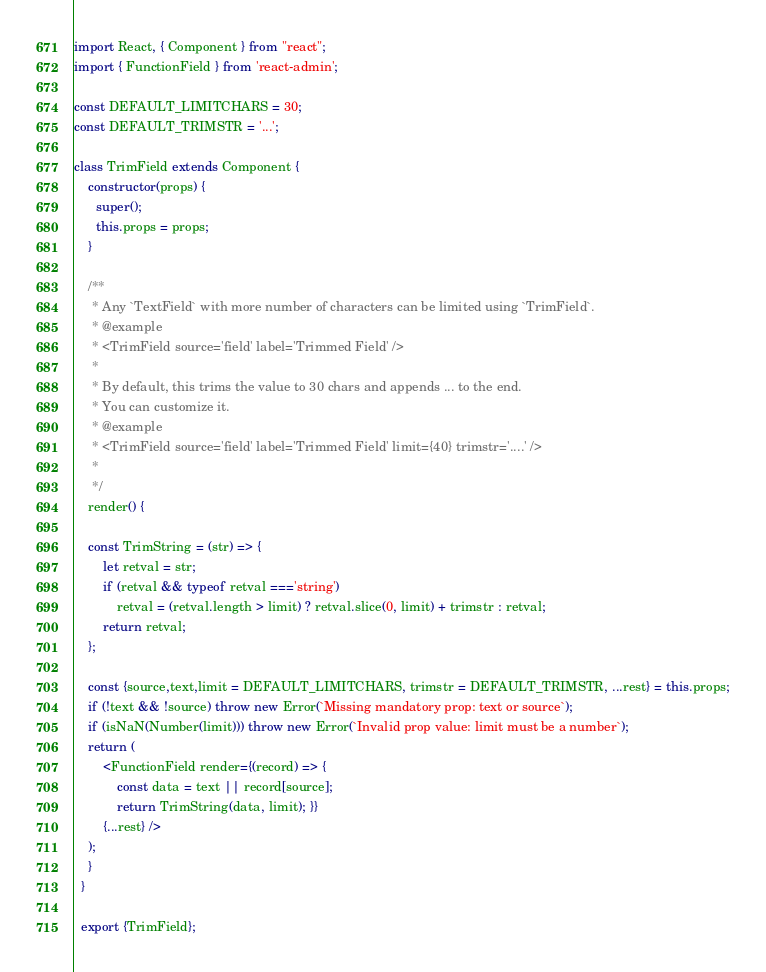<code> <loc_0><loc_0><loc_500><loc_500><_JavaScript_>import React, { Component } from "react";
import { FunctionField } from 'react-admin';

const DEFAULT_LIMITCHARS = 30;
const DEFAULT_TRIMSTR = '...';

class TrimField extends Component {
    constructor(props) {
      super();
      this.props = props;
    }

    /**
     * Any `TextField` with more number of characters can be limited using `TrimField`.
     * @example
     * <TrimField source='field' label='Trimmed Field' />
     * 
     * By default, this trims the value to 30 chars and appends ... to the end.
     * You can customize it.
     * @example
     * <TrimField source='field' label='Trimmed Field' limit={40} trimstr='....' />
     *
     */
    render() {

    const TrimString = (str) => {
        let retval = str;
        if (retval && typeof retval ==='string')
            retval = (retval.length > limit) ? retval.slice(0, limit) + trimstr : retval;
        return retval;
    };

    const {source,text,limit = DEFAULT_LIMITCHARS, trimstr = DEFAULT_TRIMSTR, ...rest} = this.props;
    if (!text && !source) throw new Error(`Missing mandatory prop: text or source`);
    if (isNaN(Number(limit))) throw new Error(`Invalid prop value: limit must be a number`);
    return (
        <FunctionField render={(record) => { 
            const data = text || record[source];
            return TrimString(data, limit); }} 
        {...rest} />
    );
    }
  }
  
  export {TrimField};
</code> 